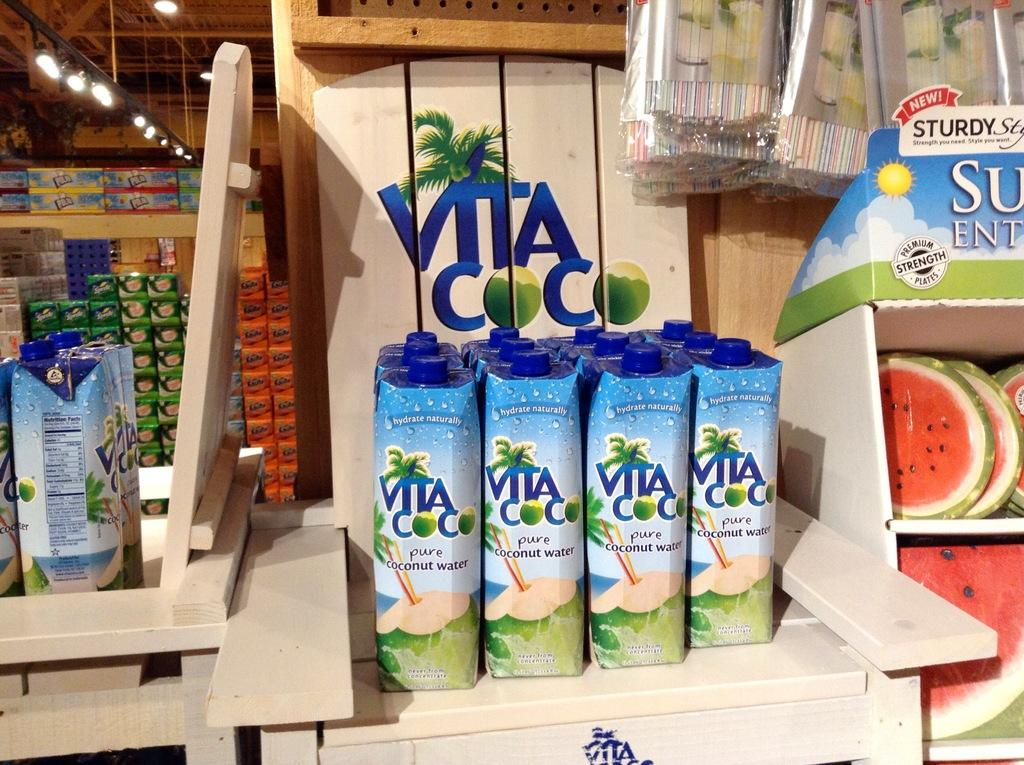<image>
Give a short and clear explanation of the subsequent image. wooden display with bottles of vita coco coconut water 